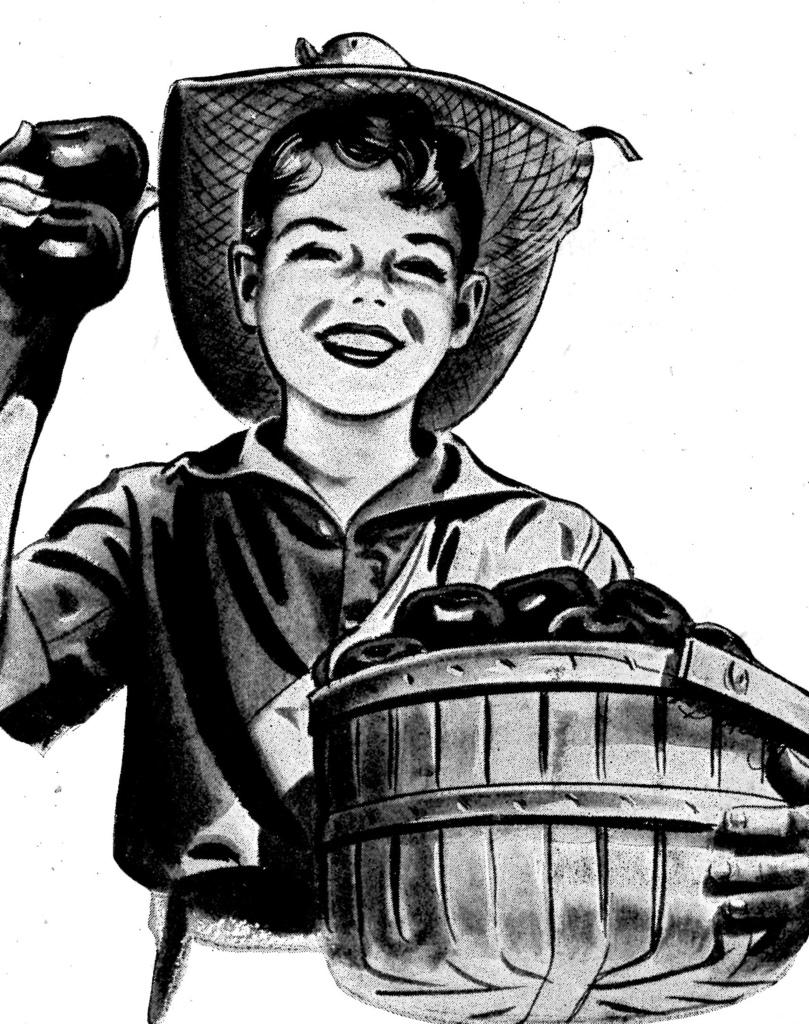What is the main subject of the painting? The painting depicts a person. What is the person holding in the painting? The person is holding a basket with apples in it. How many apples can be seen in the person's hands? The person is holding two apples in their hands. What is the person's facial expression in the painting? The person is smiling. What type of border is visible around the painting? There is no information about a border around the painting, so it cannot be determined from the provided facts. Can you tell me what time of day the painting is set in? The provided facts do not mention the time of day, so it cannot be determined from the information given. 